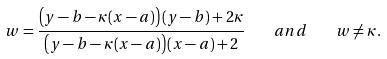<formula> <loc_0><loc_0><loc_500><loc_500>w = \frac { \left ( y - b - \kappa ( x - a ) \right ) ( y - b ) + 2 \kappa } { \left ( y - b - \kappa ( x - a ) \right ) ( x - a ) + 2 } \quad a n d \quad w \not = \kappa .</formula> 